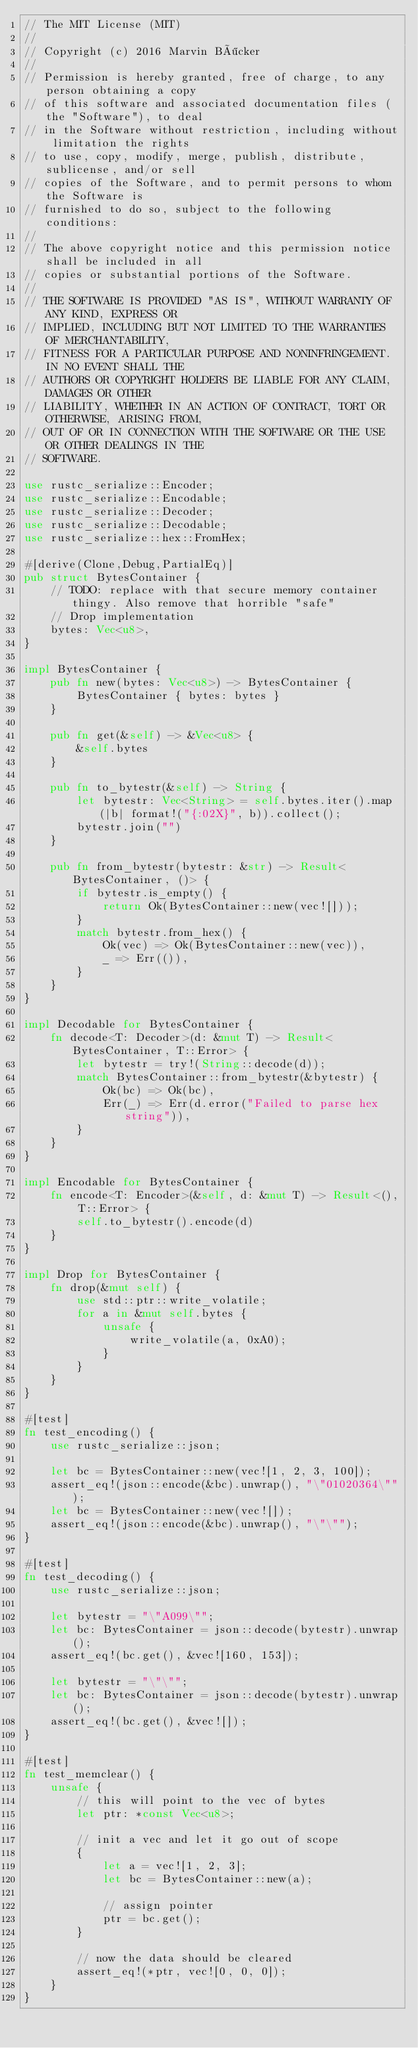Convert code to text. <code><loc_0><loc_0><loc_500><loc_500><_Rust_>// The MIT License (MIT)
//
// Copyright (c) 2016 Marvin Böcker
//
// Permission is hereby granted, free of charge, to any person obtaining a copy
// of this software and associated documentation files (the "Software"), to deal
// in the Software without restriction, including without limitation the rights
// to use, copy, modify, merge, publish, distribute, sublicense, and/or sell
// copies of the Software, and to permit persons to whom the Software is
// furnished to do so, subject to the following conditions:
//
// The above copyright notice and this permission notice shall be included in all
// copies or substantial portions of the Software.
//
// THE SOFTWARE IS PROVIDED "AS IS", WITHOUT WARRANTY OF ANY KIND, EXPRESS OR
// IMPLIED, INCLUDING BUT NOT LIMITED TO THE WARRANTIES OF MERCHANTABILITY,
// FITNESS FOR A PARTICULAR PURPOSE AND NONINFRINGEMENT. IN NO EVENT SHALL THE
// AUTHORS OR COPYRIGHT HOLDERS BE LIABLE FOR ANY CLAIM, DAMAGES OR OTHER
// LIABILITY, WHETHER IN AN ACTION OF CONTRACT, TORT OR OTHERWISE, ARISING FROM,
// OUT OF OR IN CONNECTION WITH THE SOFTWARE OR THE USE OR OTHER DEALINGS IN THE
// SOFTWARE.

use rustc_serialize::Encoder;
use rustc_serialize::Encodable;
use rustc_serialize::Decoder;
use rustc_serialize::Decodable;
use rustc_serialize::hex::FromHex;

#[derive(Clone,Debug,PartialEq)]
pub struct BytesContainer {
    // TODO: replace with that secure memory container thingy. Also remove that horrible "safe"
    // Drop implementation
    bytes: Vec<u8>,
}

impl BytesContainer {
    pub fn new(bytes: Vec<u8>) -> BytesContainer {
        BytesContainer { bytes: bytes }
    }

    pub fn get(&self) -> &Vec<u8> {
        &self.bytes
    }

    pub fn to_bytestr(&self) -> String {
        let bytestr: Vec<String> = self.bytes.iter().map(|b| format!("{:02X}", b)).collect();
        bytestr.join("")
    }

    pub fn from_bytestr(bytestr: &str) -> Result<BytesContainer, ()> {
        if bytestr.is_empty() {
            return Ok(BytesContainer::new(vec![]));
        }
        match bytestr.from_hex() {
            Ok(vec) => Ok(BytesContainer::new(vec)),
            _ => Err(()),
        }
    }
}

impl Decodable for BytesContainer {
    fn decode<T: Decoder>(d: &mut T) -> Result<BytesContainer, T::Error> {
        let bytestr = try!(String::decode(d));
        match BytesContainer::from_bytestr(&bytestr) {
            Ok(bc) => Ok(bc),
            Err(_) => Err(d.error("Failed to parse hex string")),
        }
    }
}

impl Encodable for BytesContainer {
    fn encode<T: Encoder>(&self, d: &mut T) -> Result<(), T::Error> {
        self.to_bytestr().encode(d)
    }
}

impl Drop for BytesContainer {
    fn drop(&mut self) {
        use std::ptr::write_volatile;
        for a in &mut self.bytes {
            unsafe {
                write_volatile(a, 0xA0);
            }
        }
    }
}

#[test]
fn test_encoding() {
    use rustc_serialize::json;

    let bc = BytesContainer::new(vec![1, 2, 3, 100]);
    assert_eq!(json::encode(&bc).unwrap(), "\"01020364\"");
    let bc = BytesContainer::new(vec![]);
    assert_eq!(json::encode(&bc).unwrap(), "\"\"");
}

#[test]
fn test_decoding() {
    use rustc_serialize::json;

    let bytestr = "\"A099\"";
    let bc: BytesContainer = json::decode(bytestr).unwrap();
    assert_eq!(bc.get(), &vec![160, 153]);

    let bytestr = "\"\"";
    let bc: BytesContainer = json::decode(bytestr).unwrap();
    assert_eq!(bc.get(), &vec![]);
}

#[test]
fn test_memclear() {
    unsafe {
        // this will point to the vec of bytes
        let ptr: *const Vec<u8>;

        // init a vec and let it go out of scope
        {
            let a = vec![1, 2, 3];
            let bc = BytesContainer::new(a);

            // assign pointer
            ptr = bc.get();
        }

        // now the data should be cleared
        assert_eq!(*ptr, vec![0, 0, 0]);
    }
}
</code> 